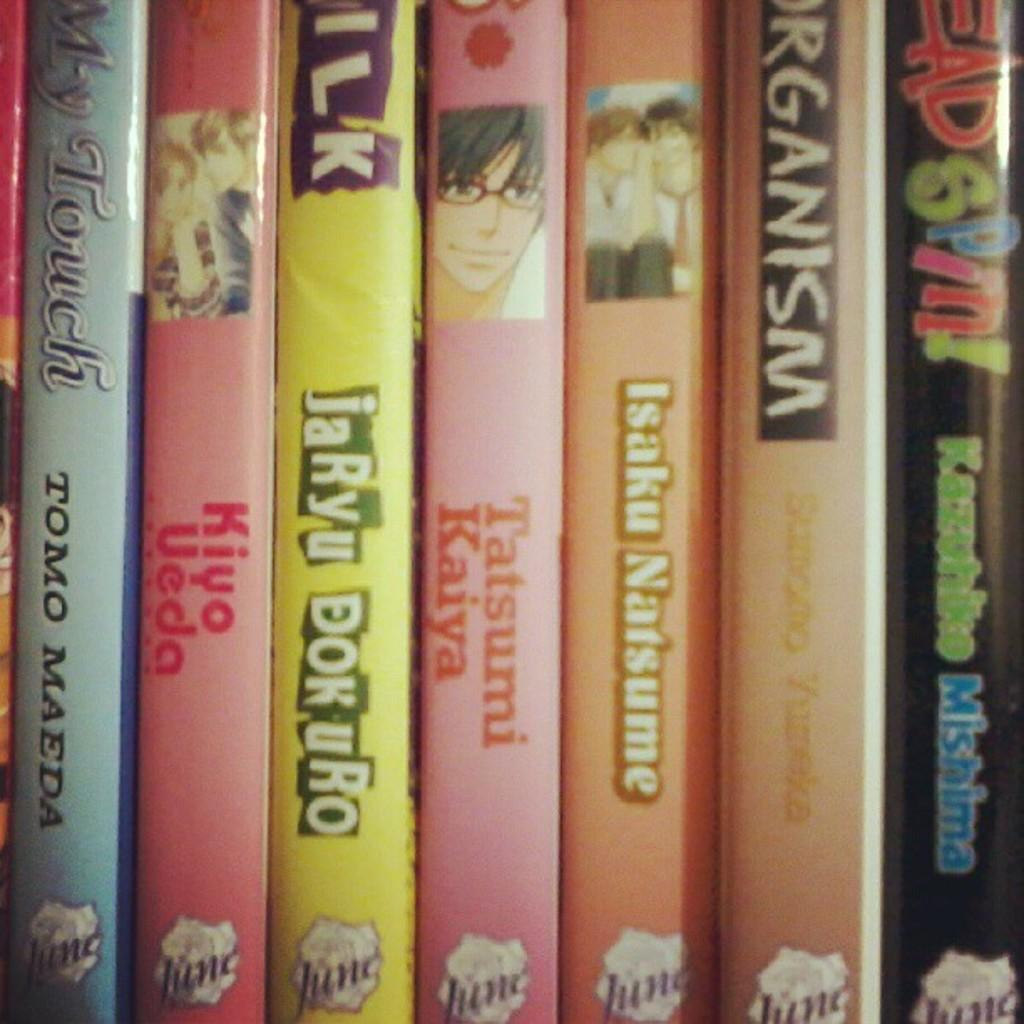<image>
Create a compact narrative representing the image presented. A stack of books and one is written by Tomo Madea 